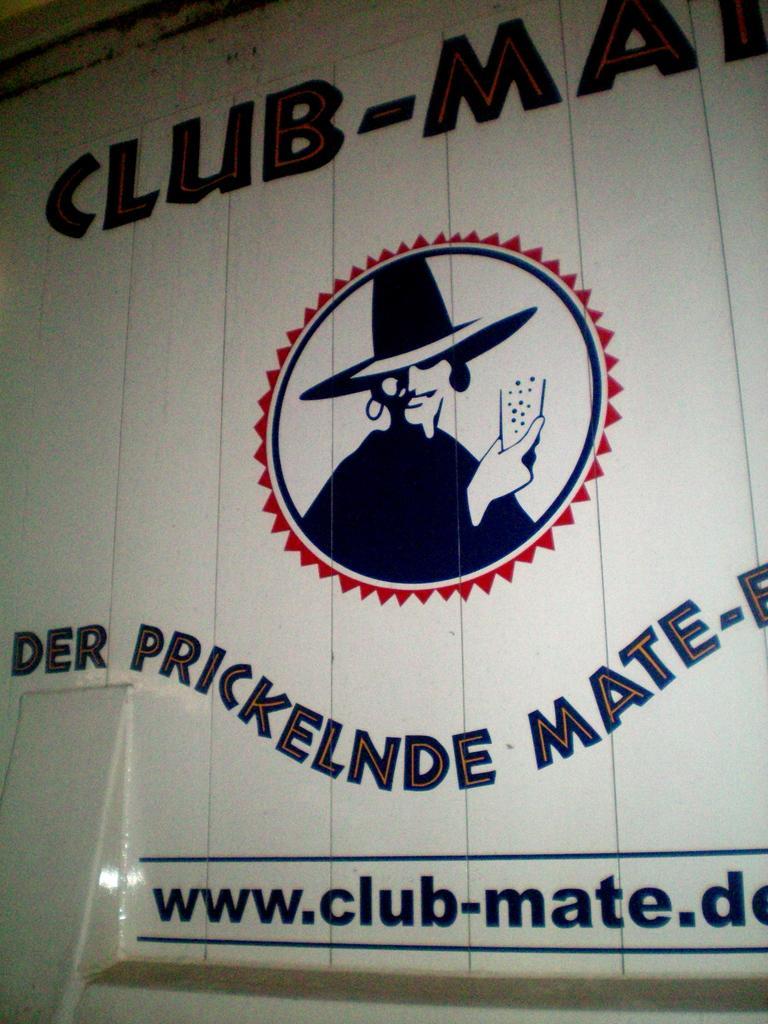Can you describe this image briefly? Here, there is a white color wall, on that wall there is CLUB-MAIN is written, and DERPRICKELENDE MATE is written on the wall. 